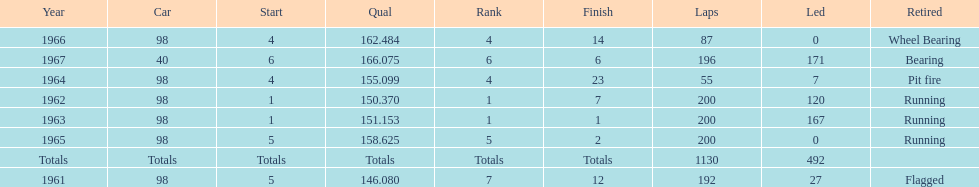Number of times to finish the races running. 3. 